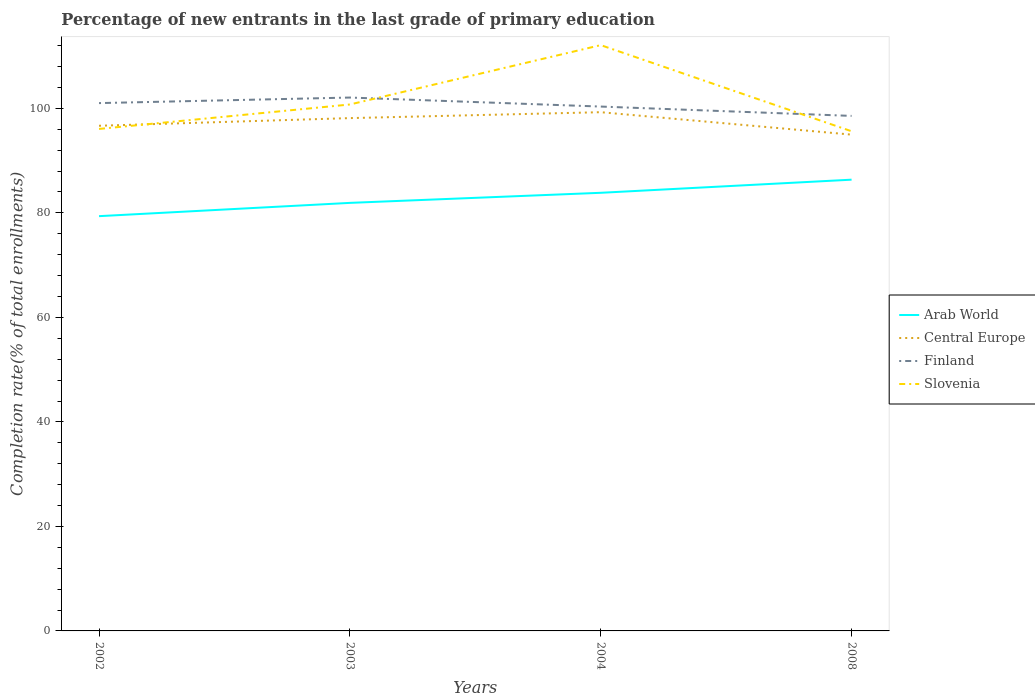Is the number of lines equal to the number of legend labels?
Offer a very short reply. Yes. Across all years, what is the maximum percentage of new entrants in Central Europe?
Make the answer very short. 94.98. In which year was the percentage of new entrants in Slovenia maximum?
Your answer should be compact. 2008. What is the total percentage of new entrants in Finland in the graph?
Provide a succinct answer. 1.73. What is the difference between the highest and the second highest percentage of new entrants in Slovenia?
Provide a succinct answer. 16.49. Is the percentage of new entrants in Arab World strictly greater than the percentage of new entrants in Finland over the years?
Your answer should be very brief. Yes. How many lines are there?
Your answer should be very brief. 4. How many years are there in the graph?
Your response must be concise. 4. What is the difference between two consecutive major ticks on the Y-axis?
Offer a terse response. 20. Are the values on the major ticks of Y-axis written in scientific E-notation?
Your answer should be very brief. No. Does the graph contain grids?
Give a very brief answer. No. Where does the legend appear in the graph?
Make the answer very short. Center right. How many legend labels are there?
Keep it short and to the point. 4. What is the title of the graph?
Make the answer very short. Percentage of new entrants in the last grade of primary education. Does "Lithuania" appear as one of the legend labels in the graph?
Make the answer very short. No. What is the label or title of the Y-axis?
Your response must be concise. Completion rate(% of total enrollments). What is the Completion rate(% of total enrollments) of Arab World in 2002?
Your response must be concise. 79.38. What is the Completion rate(% of total enrollments) in Central Europe in 2002?
Your response must be concise. 96.68. What is the Completion rate(% of total enrollments) in Finland in 2002?
Provide a short and direct response. 101.01. What is the Completion rate(% of total enrollments) in Slovenia in 2002?
Your answer should be very brief. 96.07. What is the Completion rate(% of total enrollments) of Arab World in 2003?
Offer a terse response. 81.92. What is the Completion rate(% of total enrollments) of Central Europe in 2003?
Give a very brief answer. 98.14. What is the Completion rate(% of total enrollments) in Finland in 2003?
Offer a terse response. 102.07. What is the Completion rate(% of total enrollments) in Slovenia in 2003?
Keep it short and to the point. 100.75. What is the Completion rate(% of total enrollments) of Arab World in 2004?
Ensure brevity in your answer.  83.85. What is the Completion rate(% of total enrollments) of Central Europe in 2004?
Give a very brief answer. 99.27. What is the Completion rate(% of total enrollments) in Finland in 2004?
Your response must be concise. 100.35. What is the Completion rate(% of total enrollments) in Slovenia in 2004?
Make the answer very short. 112.11. What is the Completion rate(% of total enrollments) in Arab World in 2008?
Make the answer very short. 86.36. What is the Completion rate(% of total enrollments) of Central Europe in 2008?
Keep it short and to the point. 94.98. What is the Completion rate(% of total enrollments) in Finland in 2008?
Ensure brevity in your answer.  98.56. What is the Completion rate(% of total enrollments) in Slovenia in 2008?
Provide a short and direct response. 95.62. Across all years, what is the maximum Completion rate(% of total enrollments) in Arab World?
Offer a terse response. 86.36. Across all years, what is the maximum Completion rate(% of total enrollments) in Central Europe?
Make the answer very short. 99.27. Across all years, what is the maximum Completion rate(% of total enrollments) in Finland?
Offer a terse response. 102.07. Across all years, what is the maximum Completion rate(% of total enrollments) in Slovenia?
Your answer should be compact. 112.11. Across all years, what is the minimum Completion rate(% of total enrollments) in Arab World?
Provide a succinct answer. 79.38. Across all years, what is the minimum Completion rate(% of total enrollments) in Central Europe?
Ensure brevity in your answer.  94.98. Across all years, what is the minimum Completion rate(% of total enrollments) in Finland?
Provide a succinct answer. 98.56. Across all years, what is the minimum Completion rate(% of total enrollments) in Slovenia?
Give a very brief answer. 95.62. What is the total Completion rate(% of total enrollments) of Arab World in the graph?
Give a very brief answer. 331.49. What is the total Completion rate(% of total enrollments) in Central Europe in the graph?
Ensure brevity in your answer.  389.06. What is the total Completion rate(% of total enrollments) of Finland in the graph?
Give a very brief answer. 402. What is the total Completion rate(% of total enrollments) of Slovenia in the graph?
Your response must be concise. 404.54. What is the difference between the Completion rate(% of total enrollments) in Arab World in 2002 and that in 2003?
Make the answer very short. -2.54. What is the difference between the Completion rate(% of total enrollments) of Central Europe in 2002 and that in 2003?
Provide a short and direct response. -1.46. What is the difference between the Completion rate(% of total enrollments) of Finland in 2002 and that in 2003?
Your response must be concise. -1.06. What is the difference between the Completion rate(% of total enrollments) in Slovenia in 2002 and that in 2003?
Your answer should be compact. -4.68. What is the difference between the Completion rate(% of total enrollments) of Arab World in 2002 and that in 2004?
Ensure brevity in your answer.  -4.47. What is the difference between the Completion rate(% of total enrollments) in Central Europe in 2002 and that in 2004?
Your response must be concise. -2.6. What is the difference between the Completion rate(% of total enrollments) in Finland in 2002 and that in 2004?
Offer a terse response. 0.66. What is the difference between the Completion rate(% of total enrollments) of Slovenia in 2002 and that in 2004?
Keep it short and to the point. -16.04. What is the difference between the Completion rate(% of total enrollments) in Arab World in 2002 and that in 2008?
Offer a very short reply. -6.98. What is the difference between the Completion rate(% of total enrollments) in Central Europe in 2002 and that in 2008?
Provide a succinct answer. 1.7. What is the difference between the Completion rate(% of total enrollments) in Finland in 2002 and that in 2008?
Ensure brevity in your answer.  2.45. What is the difference between the Completion rate(% of total enrollments) in Slovenia in 2002 and that in 2008?
Keep it short and to the point. 0.45. What is the difference between the Completion rate(% of total enrollments) of Arab World in 2003 and that in 2004?
Give a very brief answer. -1.93. What is the difference between the Completion rate(% of total enrollments) in Central Europe in 2003 and that in 2004?
Offer a terse response. -1.13. What is the difference between the Completion rate(% of total enrollments) in Finland in 2003 and that in 2004?
Keep it short and to the point. 1.73. What is the difference between the Completion rate(% of total enrollments) of Slovenia in 2003 and that in 2004?
Keep it short and to the point. -11.36. What is the difference between the Completion rate(% of total enrollments) in Arab World in 2003 and that in 2008?
Offer a very short reply. -4.44. What is the difference between the Completion rate(% of total enrollments) in Central Europe in 2003 and that in 2008?
Provide a short and direct response. 3.16. What is the difference between the Completion rate(% of total enrollments) of Finland in 2003 and that in 2008?
Offer a terse response. 3.51. What is the difference between the Completion rate(% of total enrollments) in Slovenia in 2003 and that in 2008?
Your answer should be very brief. 5.13. What is the difference between the Completion rate(% of total enrollments) in Arab World in 2004 and that in 2008?
Provide a short and direct response. -2.51. What is the difference between the Completion rate(% of total enrollments) of Central Europe in 2004 and that in 2008?
Your answer should be very brief. 4.29. What is the difference between the Completion rate(% of total enrollments) in Finland in 2004 and that in 2008?
Your answer should be compact. 1.79. What is the difference between the Completion rate(% of total enrollments) in Slovenia in 2004 and that in 2008?
Your answer should be very brief. 16.49. What is the difference between the Completion rate(% of total enrollments) in Arab World in 2002 and the Completion rate(% of total enrollments) in Central Europe in 2003?
Offer a terse response. -18.76. What is the difference between the Completion rate(% of total enrollments) of Arab World in 2002 and the Completion rate(% of total enrollments) of Finland in 2003?
Your answer should be compact. -22.7. What is the difference between the Completion rate(% of total enrollments) in Arab World in 2002 and the Completion rate(% of total enrollments) in Slovenia in 2003?
Your answer should be compact. -21.37. What is the difference between the Completion rate(% of total enrollments) in Central Europe in 2002 and the Completion rate(% of total enrollments) in Finland in 2003?
Give a very brief answer. -5.4. What is the difference between the Completion rate(% of total enrollments) of Central Europe in 2002 and the Completion rate(% of total enrollments) of Slovenia in 2003?
Your answer should be compact. -4.07. What is the difference between the Completion rate(% of total enrollments) of Finland in 2002 and the Completion rate(% of total enrollments) of Slovenia in 2003?
Your answer should be very brief. 0.26. What is the difference between the Completion rate(% of total enrollments) of Arab World in 2002 and the Completion rate(% of total enrollments) of Central Europe in 2004?
Your answer should be very brief. -19.9. What is the difference between the Completion rate(% of total enrollments) of Arab World in 2002 and the Completion rate(% of total enrollments) of Finland in 2004?
Provide a succinct answer. -20.97. What is the difference between the Completion rate(% of total enrollments) in Arab World in 2002 and the Completion rate(% of total enrollments) in Slovenia in 2004?
Make the answer very short. -32.73. What is the difference between the Completion rate(% of total enrollments) in Central Europe in 2002 and the Completion rate(% of total enrollments) in Finland in 2004?
Offer a very short reply. -3.67. What is the difference between the Completion rate(% of total enrollments) of Central Europe in 2002 and the Completion rate(% of total enrollments) of Slovenia in 2004?
Ensure brevity in your answer.  -15.43. What is the difference between the Completion rate(% of total enrollments) in Finland in 2002 and the Completion rate(% of total enrollments) in Slovenia in 2004?
Give a very brief answer. -11.09. What is the difference between the Completion rate(% of total enrollments) of Arab World in 2002 and the Completion rate(% of total enrollments) of Central Europe in 2008?
Your response must be concise. -15.6. What is the difference between the Completion rate(% of total enrollments) of Arab World in 2002 and the Completion rate(% of total enrollments) of Finland in 2008?
Provide a short and direct response. -19.19. What is the difference between the Completion rate(% of total enrollments) in Arab World in 2002 and the Completion rate(% of total enrollments) in Slovenia in 2008?
Give a very brief answer. -16.25. What is the difference between the Completion rate(% of total enrollments) of Central Europe in 2002 and the Completion rate(% of total enrollments) of Finland in 2008?
Offer a very short reply. -1.89. What is the difference between the Completion rate(% of total enrollments) in Central Europe in 2002 and the Completion rate(% of total enrollments) in Slovenia in 2008?
Offer a very short reply. 1.05. What is the difference between the Completion rate(% of total enrollments) of Finland in 2002 and the Completion rate(% of total enrollments) of Slovenia in 2008?
Your answer should be compact. 5.39. What is the difference between the Completion rate(% of total enrollments) in Arab World in 2003 and the Completion rate(% of total enrollments) in Central Europe in 2004?
Provide a short and direct response. -17.35. What is the difference between the Completion rate(% of total enrollments) in Arab World in 2003 and the Completion rate(% of total enrollments) in Finland in 2004?
Provide a succinct answer. -18.43. What is the difference between the Completion rate(% of total enrollments) in Arab World in 2003 and the Completion rate(% of total enrollments) in Slovenia in 2004?
Keep it short and to the point. -30.19. What is the difference between the Completion rate(% of total enrollments) of Central Europe in 2003 and the Completion rate(% of total enrollments) of Finland in 2004?
Your answer should be very brief. -2.21. What is the difference between the Completion rate(% of total enrollments) of Central Europe in 2003 and the Completion rate(% of total enrollments) of Slovenia in 2004?
Your answer should be compact. -13.97. What is the difference between the Completion rate(% of total enrollments) in Finland in 2003 and the Completion rate(% of total enrollments) in Slovenia in 2004?
Offer a very short reply. -10.03. What is the difference between the Completion rate(% of total enrollments) in Arab World in 2003 and the Completion rate(% of total enrollments) in Central Europe in 2008?
Your response must be concise. -13.06. What is the difference between the Completion rate(% of total enrollments) in Arab World in 2003 and the Completion rate(% of total enrollments) in Finland in 2008?
Your response must be concise. -16.65. What is the difference between the Completion rate(% of total enrollments) in Arab World in 2003 and the Completion rate(% of total enrollments) in Slovenia in 2008?
Make the answer very short. -13.7. What is the difference between the Completion rate(% of total enrollments) of Central Europe in 2003 and the Completion rate(% of total enrollments) of Finland in 2008?
Your response must be concise. -0.42. What is the difference between the Completion rate(% of total enrollments) of Central Europe in 2003 and the Completion rate(% of total enrollments) of Slovenia in 2008?
Make the answer very short. 2.52. What is the difference between the Completion rate(% of total enrollments) of Finland in 2003 and the Completion rate(% of total enrollments) of Slovenia in 2008?
Your answer should be compact. 6.45. What is the difference between the Completion rate(% of total enrollments) of Arab World in 2004 and the Completion rate(% of total enrollments) of Central Europe in 2008?
Make the answer very short. -11.13. What is the difference between the Completion rate(% of total enrollments) in Arab World in 2004 and the Completion rate(% of total enrollments) in Finland in 2008?
Offer a very short reply. -14.72. What is the difference between the Completion rate(% of total enrollments) in Arab World in 2004 and the Completion rate(% of total enrollments) in Slovenia in 2008?
Ensure brevity in your answer.  -11.78. What is the difference between the Completion rate(% of total enrollments) in Central Europe in 2004 and the Completion rate(% of total enrollments) in Finland in 2008?
Provide a short and direct response. 0.71. What is the difference between the Completion rate(% of total enrollments) of Central Europe in 2004 and the Completion rate(% of total enrollments) of Slovenia in 2008?
Provide a succinct answer. 3.65. What is the difference between the Completion rate(% of total enrollments) in Finland in 2004 and the Completion rate(% of total enrollments) in Slovenia in 2008?
Your response must be concise. 4.73. What is the average Completion rate(% of total enrollments) of Arab World per year?
Make the answer very short. 82.87. What is the average Completion rate(% of total enrollments) of Central Europe per year?
Provide a succinct answer. 97.27. What is the average Completion rate(% of total enrollments) in Finland per year?
Make the answer very short. 100.5. What is the average Completion rate(% of total enrollments) in Slovenia per year?
Provide a short and direct response. 101.14. In the year 2002, what is the difference between the Completion rate(% of total enrollments) in Arab World and Completion rate(% of total enrollments) in Central Europe?
Your response must be concise. -17.3. In the year 2002, what is the difference between the Completion rate(% of total enrollments) of Arab World and Completion rate(% of total enrollments) of Finland?
Keep it short and to the point. -21.64. In the year 2002, what is the difference between the Completion rate(% of total enrollments) of Arab World and Completion rate(% of total enrollments) of Slovenia?
Your answer should be very brief. -16.69. In the year 2002, what is the difference between the Completion rate(% of total enrollments) in Central Europe and Completion rate(% of total enrollments) in Finland?
Your answer should be compact. -4.34. In the year 2002, what is the difference between the Completion rate(% of total enrollments) of Central Europe and Completion rate(% of total enrollments) of Slovenia?
Ensure brevity in your answer.  0.61. In the year 2002, what is the difference between the Completion rate(% of total enrollments) of Finland and Completion rate(% of total enrollments) of Slovenia?
Give a very brief answer. 4.94. In the year 2003, what is the difference between the Completion rate(% of total enrollments) of Arab World and Completion rate(% of total enrollments) of Central Europe?
Your response must be concise. -16.22. In the year 2003, what is the difference between the Completion rate(% of total enrollments) of Arab World and Completion rate(% of total enrollments) of Finland?
Your answer should be very brief. -20.16. In the year 2003, what is the difference between the Completion rate(% of total enrollments) of Arab World and Completion rate(% of total enrollments) of Slovenia?
Make the answer very short. -18.83. In the year 2003, what is the difference between the Completion rate(% of total enrollments) of Central Europe and Completion rate(% of total enrollments) of Finland?
Provide a short and direct response. -3.93. In the year 2003, what is the difference between the Completion rate(% of total enrollments) of Central Europe and Completion rate(% of total enrollments) of Slovenia?
Keep it short and to the point. -2.61. In the year 2003, what is the difference between the Completion rate(% of total enrollments) of Finland and Completion rate(% of total enrollments) of Slovenia?
Keep it short and to the point. 1.33. In the year 2004, what is the difference between the Completion rate(% of total enrollments) of Arab World and Completion rate(% of total enrollments) of Central Europe?
Offer a very short reply. -15.43. In the year 2004, what is the difference between the Completion rate(% of total enrollments) in Arab World and Completion rate(% of total enrollments) in Finland?
Your response must be concise. -16.5. In the year 2004, what is the difference between the Completion rate(% of total enrollments) of Arab World and Completion rate(% of total enrollments) of Slovenia?
Keep it short and to the point. -28.26. In the year 2004, what is the difference between the Completion rate(% of total enrollments) of Central Europe and Completion rate(% of total enrollments) of Finland?
Your answer should be compact. -1.08. In the year 2004, what is the difference between the Completion rate(% of total enrollments) in Central Europe and Completion rate(% of total enrollments) in Slovenia?
Your response must be concise. -12.84. In the year 2004, what is the difference between the Completion rate(% of total enrollments) in Finland and Completion rate(% of total enrollments) in Slovenia?
Offer a very short reply. -11.76. In the year 2008, what is the difference between the Completion rate(% of total enrollments) of Arab World and Completion rate(% of total enrollments) of Central Europe?
Give a very brief answer. -8.62. In the year 2008, what is the difference between the Completion rate(% of total enrollments) of Arab World and Completion rate(% of total enrollments) of Finland?
Your answer should be compact. -12.21. In the year 2008, what is the difference between the Completion rate(% of total enrollments) of Arab World and Completion rate(% of total enrollments) of Slovenia?
Your answer should be very brief. -9.26. In the year 2008, what is the difference between the Completion rate(% of total enrollments) in Central Europe and Completion rate(% of total enrollments) in Finland?
Provide a short and direct response. -3.58. In the year 2008, what is the difference between the Completion rate(% of total enrollments) of Central Europe and Completion rate(% of total enrollments) of Slovenia?
Make the answer very short. -0.64. In the year 2008, what is the difference between the Completion rate(% of total enrollments) of Finland and Completion rate(% of total enrollments) of Slovenia?
Make the answer very short. 2.94. What is the ratio of the Completion rate(% of total enrollments) in Central Europe in 2002 to that in 2003?
Offer a terse response. 0.99. What is the ratio of the Completion rate(% of total enrollments) in Finland in 2002 to that in 2003?
Provide a succinct answer. 0.99. What is the ratio of the Completion rate(% of total enrollments) in Slovenia in 2002 to that in 2003?
Keep it short and to the point. 0.95. What is the ratio of the Completion rate(% of total enrollments) of Arab World in 2002 to that in 2004?
Your answer should be compact. 0.95. What is the ratio of the Completion rate(% of total enrollments) in Central Europe in 2002 to that in 2004?
Offer a terse response. 0.97. What is the ratio of the Completion rate(% of total enrollments) of Finland in 2002 to that in 2004?
Give a very brief answer. 1.01. What is the ratio of the Completion rate(% of total enrollments) of Slovenia in 2002 to that in 2004?
Your answer should be compact. 0.86. What is the ratio of the Completion rate(% of total enrollments) of Arab World in 2002 to that in 2008?
Offer a terse response. 0.92. What is the ratio of the Completion rate(% of total enrollments) of Central Europe in 2002 to that in 2008?
Give a very brief answer. 1.02. What is the ratio of the Completion rate(% of total enrollments) of Finland in 2002 to that in 2008?
Give a very brief answer. 1.02. What is the ratio of the Completion rate(% of total enrollments) of Central Europe in 2003 to that in 2004?
Ensure brevity in your answer.  0.99. What is the ratio of the Completion rate(% of total enrollments) in Finland in 2003 to that in 2004?
Your response must be concise. 1.02. What is the ratio of the Completion rate(% of total enrollments) of Slovenia in 2003 to that in 2004?
Offer a terse response. 0.9. What is the ratio of the Completion rate(% of total enrollments) in Arab World in 2003 to that in 2008?
Your answer should be compact. 0.95. What is the ratio of the Completion rate(% of total enrollments) in Central Europe in 2003 to that in 2008?
Give a very brief answer. 1.03. What is the ratio of the Completion rate(% of total enrollments) of Finland in 2003 to that in 2008?
Offer a very short reply. 1.04. What is the ratio of the Completion rate(% of total enrollments) in Slovenia in 2003 to that in 2008?
Ensure brevity in your answer.  1.05. What is the ratio of the Completion rate(% of total enrollments) in Arab World in 2004 to that in 2008?
Provide a succinct answer. 0.97. What is the ratio of the Completion rate(% of total enrollments) in Central Europe in 2004 to that in 2008?
Your answer should be very brief. 1.05. What is the ratio of the Completion rate(% of total enrollments) in Finland in 2004 to that in 2008?
Your answer should be compact. 1.02. What is the ratio of the Completion rate(% of total enrollments) in Slovenia in 2004 to that in 2008?
Your answer should be compact. 1.17. What is the difference between the highest and the second highest Completion rate(% of total enrollments) in Arab World?
Provide a succinct answer. 2.51. What is the difference between the highest and the second highest Completion rate(% of total enrollments) of Central Europe?
Make the answer very short. 1.13. What is the difference between the highest and the second highest Completion rate(% of total enrollments) of Finland?
Keep it short and to the point. 1.06. What is the difference between the highest and the second highest Completion rate(% of total enrollments) of Slovenia?
Make the answer very short. 11.36. What is the difference between the highest and the lowest Completion rate(% of total enrollments) of Arab World?
Make the answer very short. 6.98. What is the difference between the highest and the lowest Completion rate(% of total enrollments) of Central Europe?
Ensure brevity in your answer.  4.29. What is the difference between the highest and the lowest Completion rate(% of total enrollments) in Finland?
Ensure brevity in your answer.  3.51. What is the difference between the highest and the lowest Completion rate(% of total enrollments) in Slovenia?
Keep it short and to the point. 16.49. 